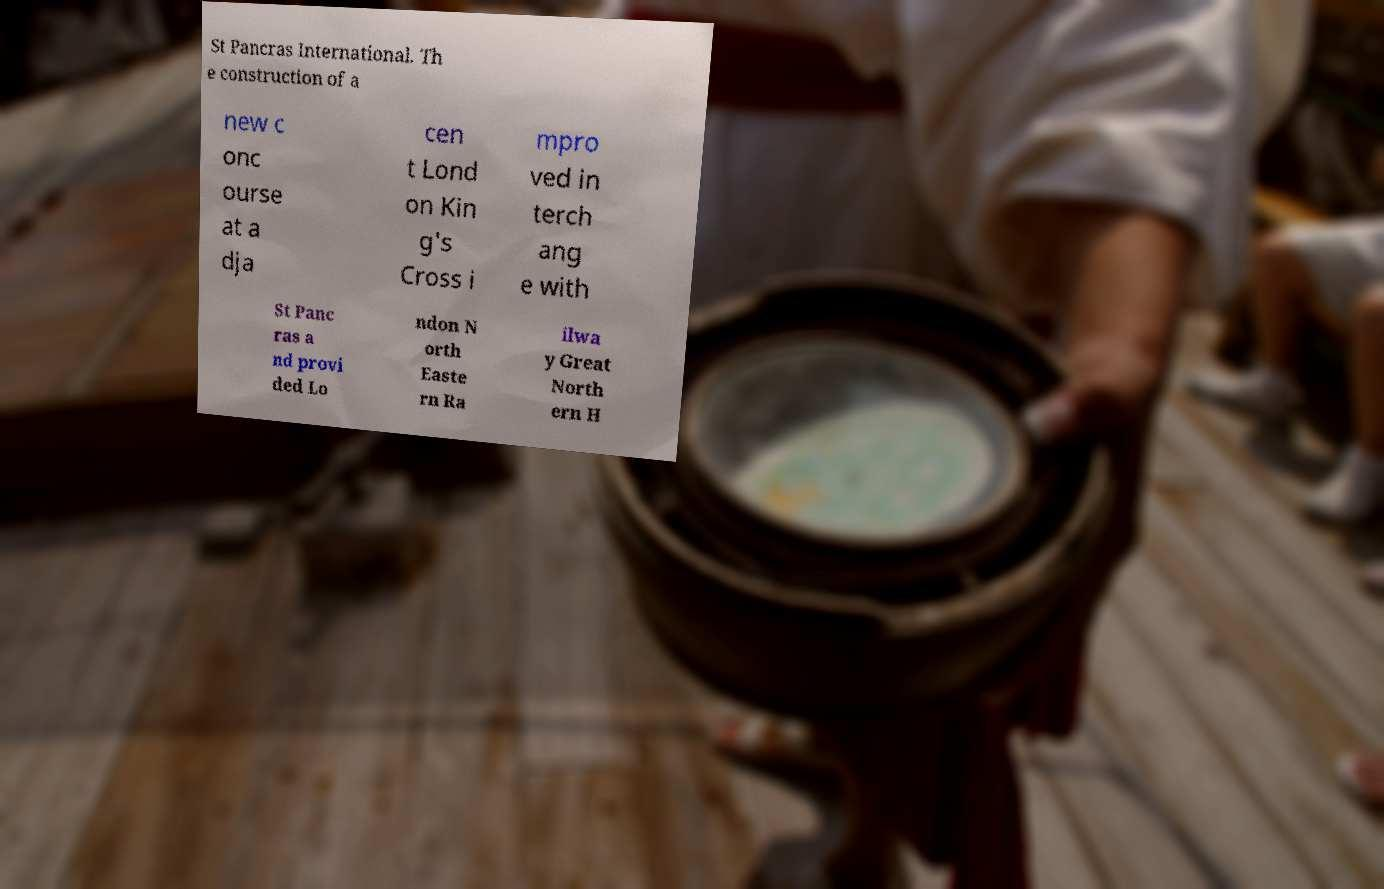Please read and relay the text visible in this image. What does it say? St Pancras International. Th e construction of a new c onc ourse at a dja cen t Lond on Kin g's Cross i mpro ved in terch ang e with St Panc ras a nd provi ded Lo ndon N orth Easte rn Ra ilwa y Great North ern H 